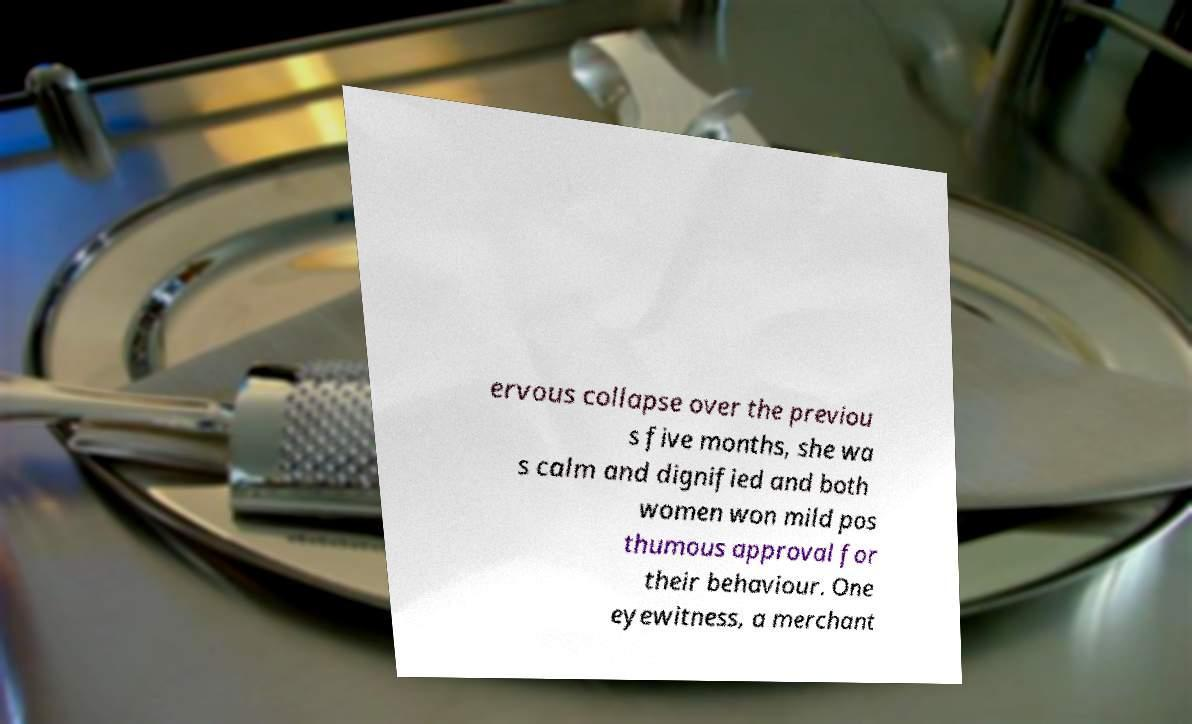Please identify and transcribe the text found in this image. ervous collapse over the previou s five months, she wa s calm and dignified and both women won mild pos thumous approval for their behaviour. One eyewitness, a merchant 